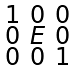<formula> <loc_0><loc_0><loc_500><loc_500>\begin{smallmatrix} 1 & 0 & 0 \\ 0 & E & 0 \\ 0 & 0 & 1 \end{smallmatrix}</formula> 